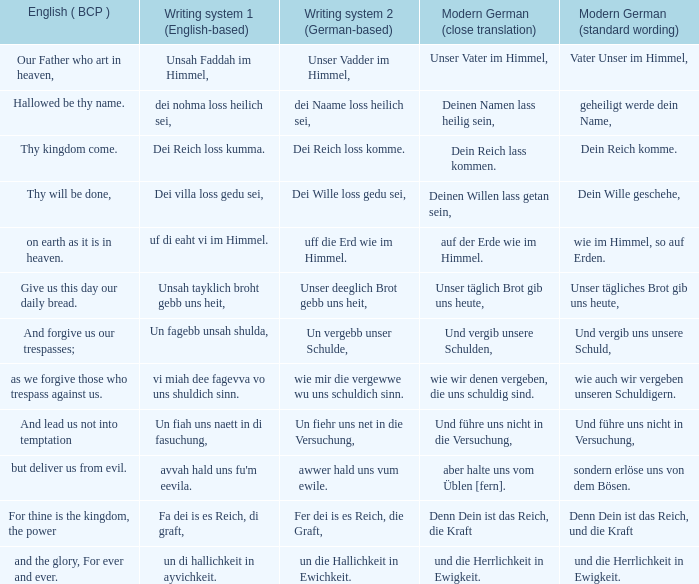What is the modern german standard wording for the german based writing system 2 phrase "wie mir die vergewwe wu uns schuldich sinn."? Wie auch wir vergeben unseren schuldigern. Can you give me this table as a dict? {'header': ['English ( BCP )', 'Writing system 1 (English-based)', 'Writing system 2 (German-based)', 'Modern German (close translation)', 'Modern German (standard wording)'], 'rows': [['Our Father who art in heaven,', 'Unsah Faddah im Himmel,', 'Unser Vadder im Himmel,', 'Unser Vater im Himmel,', 'Vater Unser im Himmel,'], ['Hallowed be thy name.', 'dei nohma loss heilich sei,', 'dei Naame loss heilich sei,', 'Deinen Namen lass heilig sein,', 'geheiligt werde dein Name,'], ['Thy kingdom come.', 'Dei Reich loss kumma.', 'Dei Reich loss komme.', 'Dein Reich lass kommen.', 'Dein Reich komme.'], ['Thy will be done,', 'Dei villa loss gedu sei,', 'Dei Wille loss gedu sei,', 'Deinen Willen lass getan sein,', 'Dein Wille geschehe,'], ['on earth as it is in heaven.', 'uf di eaht vi im Himmel.', 'uff die Erd wie im Himmel.', 'auf der Erde wie im Himmel.', 'wie im Himmel, so auf Erden.'], ['Give us this day our daily bread.', 'Unsah tayklich broht gebb uns heit,', 'Unser deeglich Brot gebb uns heit,', 'Unser täglich Brot gib uns heute,', 'Unser tägliches Brot gib uns heute,'], ['And forgive us our trespasses;', 'Un fagebb unsah shulda,', 'Un vergebb unser Schulde,', 'Und vergib unsere Schulden,', 'Und vergib uns unsere Schuld,'], ['as we forgive those who trespass against us.', 'vi miah dee fagevva vo uns shuldich sinn.', 'wie mir die vergewwe wu uns schuldich sinn.', 'wie wir denen vergeben, die uns schuldig sind.', 'wie auch wir vergeben unseren Schuldigern.'], ['And lead us not into temptation', 'Un fiah uns naett in di fasuchung,', 'Un fiehr uns net in die Versuchung,', 'Und führe uns nicht in die Versuchung,', 'Und führe uns nicht in Versuchung,'], ['but deliver us from evil.', "avvah hald uns fu'm eevila.", 'awwer hald uns vum ewile.', 'aber halte uns vom Üblen [fern].', 'sondern erlöse uns von dem Bösen.'], ['For thine is the kingdom, the power', 'Fa dei is es Reich, di graft,', 'Fer dei is es Reich, die Graft,', 'Denn Dein ist das Reich, die Kraft', 'Denn Dein ist das Reich, und die Kraft'], ['and the glory, For ever and ever.', 'un di hallichkeit in ayvichkeit.', 'un die Hallichkeit in Ewichkeit.', 'und die Herrlichkeit in Ewigkeit.', 'und die Herrlichkeit in Ewigkeit.']]} 